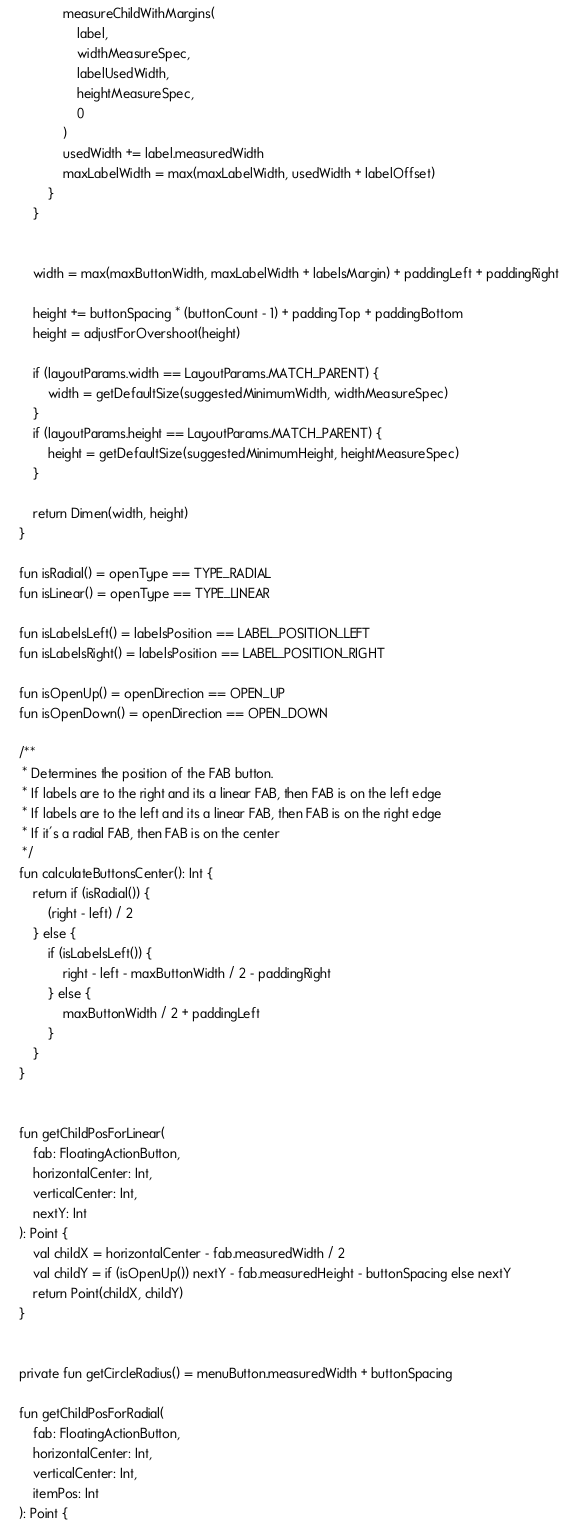Convert code to text. <code><loc_0><loc_0><loc_500><loc_500><_Kotlin_>                measureChildWithMargins(
                    label,
                    widthMeasureSpec,
                    labelUsedWidth,
                    heightMeasureSpec,
                    0
                )
                usedWidth += label.measuredWidth
                maxLabelWidth = max(maxLabelWidth, usedWidth + labelOffset)
            }
        }


        width = max(maxButtonWidth, maxLabelWidth + labelsMargin) + paddingLeft + paddingRight

        height += buttonSpacing * (buttonCount - 1) + paddingTop + paddingBottom
        height = adjustForOvershoot(height)

        if (layoutParams.width == LayoutParams.MATCH_PARENT) {
            width = getDefaultSize(suggestedMinimumWidth, widthMeasureSpec)
        }
        if (layoutParams.height == LayoutParams.MATCH_PARENT) {
            height = getDefaultSize(suggestedMinimumHeight, heightMeasureSpec)
        }

        return Dimen(width, height)
    }

    fun isRadial() = openType == TYPE_RADIAL
    fun isLinear() = openType == TYPE_LINEAR

    fun isLabelsLeft() = labelsPosition == LABEL_POSITION_LEFT
    fun isLabelsRight() = labelsPosition == LABEL_POSITION_RIGHT

    fun isOpenUp() = openDirection == OPEN_UP
    fun isOpenDown() = openDirection == OPEN_DOWN

    /**
     * Determines the position of the FAB button.
     * If labels are to the right and its a linear FAB, then FAB is on the left edge
     * If labels are to the left and its a linear FAB, then FAB is on the right edge
     * If it's a radial FAB, then FAB is on the center
     */
    fun calculateButtonsCenter(): Int {
        return if (isRadial()) {
            (right - left) / 2
        } else {
            if (isLabelsLeft()) {
                right - left - maxButtonWidth / 2 - paddingRight
            } else {
                maxButtonWidth / 2 + paddingLeft
            }
        }
    }


    fun getChildPosForLinear(
        fab: FloatingActionButton,
        horizontalCenter: Int,
        verticalCenter: Int,
        nextY: Int
    ): Point {
        val childX = horizontalCenter - fab.measuredWidth / 2
        val childY = if (isOpenUp()) nextY - fab.measuredHeight - buttonSpacing else nextY
        return Point(childX, childY)
    }


    private fun getCircleRadius() = menuButton.measuredWidth + buttonSpacing

    fun getChildPosForRadial(
        fab: FloatingActionButton,
        horizontalCenter: Int,
        verticalCenter: Int,
        itemPos: Int
    ): Point {
</code> 